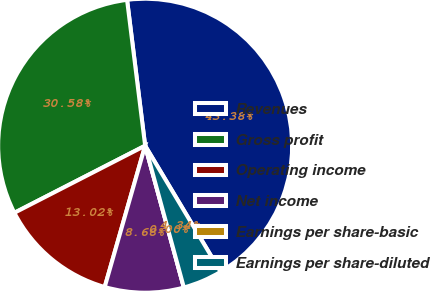Convert chart to OTSL. <chart><loc_0><loc_0><loc_500><loc_500><pie_chart><fcel>Revenues<fcel>Gross profit<fcel>Operating income<fcel>Net income<fcel>Earnings per share-basic<fcel>Earnings per share-diluted<nl><fcel>43.38%<fcel>30.58%<fcel>13.02%<fcel>8.68%<fcel>0.0%<fcel>4.34%<nl></chart> 